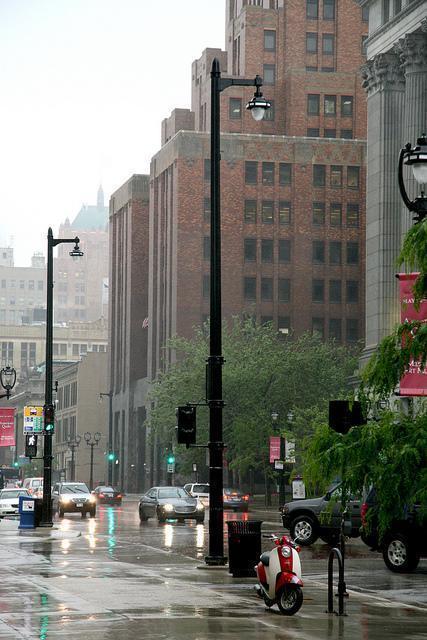What has caused the roads to look reflective?
Pick the right solution, then justify: 'Answer: answer
Rationale: rationale.'
Options: Ice, snow, wax, rain. Answer: rain.
Rationale: Cars on a street are using their wipers and the road is shiny with water puddling in various areas. 